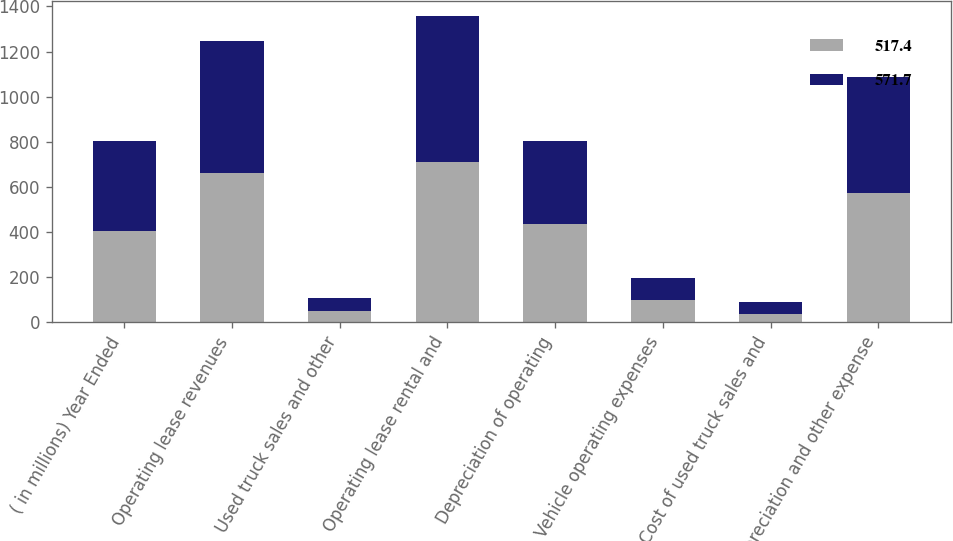Convert chart. <chart><loc_0><loc_0><loc_500><loc_500><stacked_bar_chart><ecel><fcel>( in millions) Year Ended<fcel>Operating lease revenues<fcel>Used truck sales and other<fcel>Operating lease rental and<fcel>Depreciation of operating<fcel>Vehicle operating expenses<fcel>Cost of used truck sales and<fcel>Depreciation and other expense<nl><fcel>517.4<fcel>402.65<fcel>663<fcel>49.1<fcel>712.1<fcel>435.4<fcel>98.1<fcel>38.2<fcel>571.7<nl><fcel>571.7<fcel>402.65<fcel>585.9<fcel>59.2<fcel>645.1<fcel>369.9<fcel>97<fcel>50.5<fcel>517.4<nl></chart> 